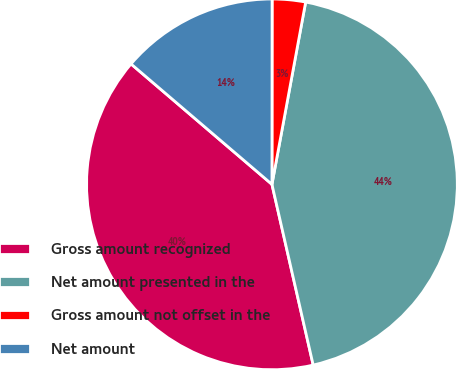Convert chart. <chart><loc_0><loc_0><loc_500><loc_500><pie_chart><fcel>Gross amount recognized<fcel>Net amount presented in the<fcel>Gross amount not offset in the<fcel>Net amount<nl><fcel>39.83%<fcel>43.52%<fcel>2.9%<fcel>13.76%<nl></chart> 